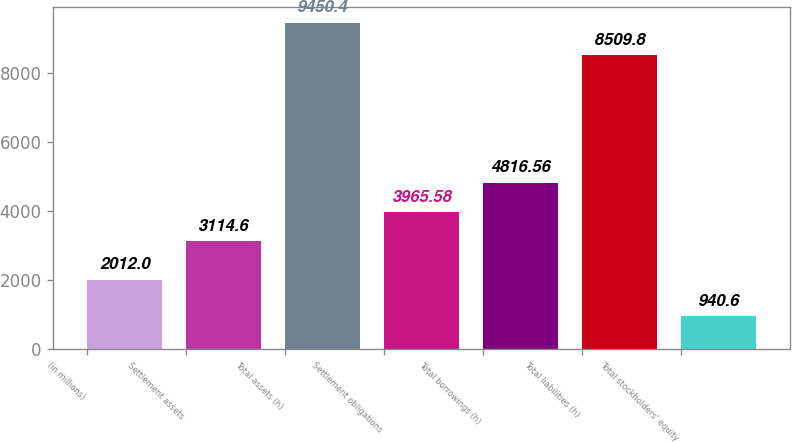Convert chart. <chart><loc_0><loc_0><loc_500><loc_500><bar_chart><fcel>(in millions)<fcel>Settlement assets<fcel>Total assets (h)<fcel>Settlement obligations<fcel>Total borrowings (h)<fcel>Total liabilities (h)<fcel>Total stockholders' equity<nl><fcel>2012<fcel>3114.6<fcel>9450.4<fcel>3965.58<fcel>4816.56<fcel>8509.8<fcel>940.6<nl></chart> 